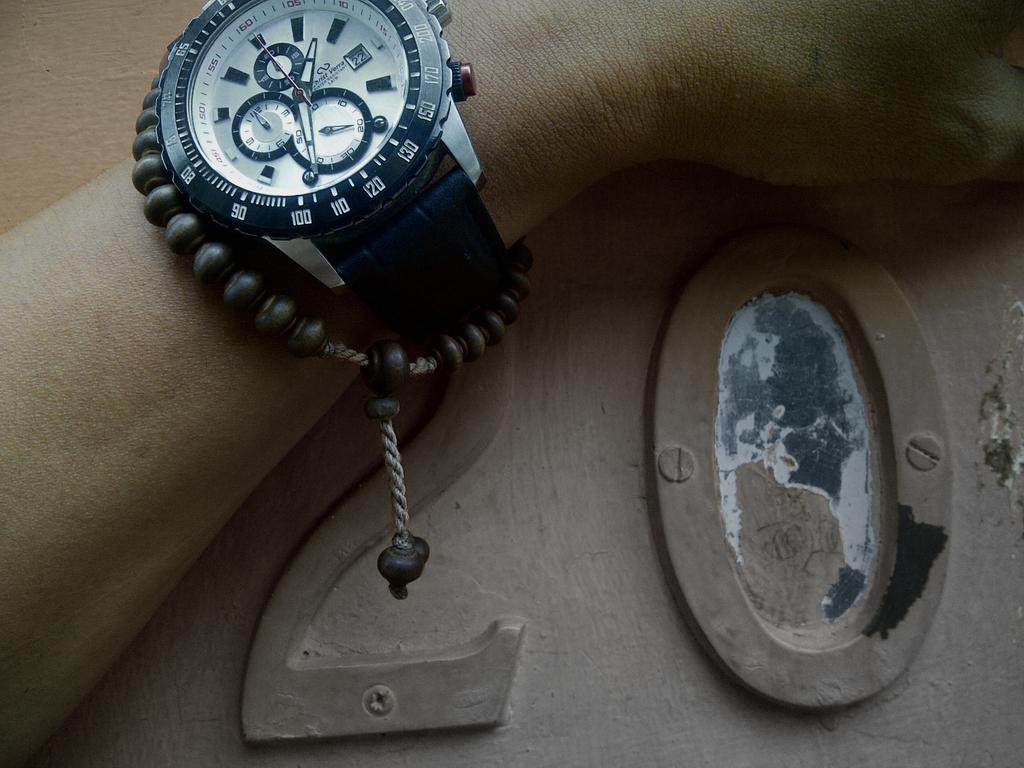Provide a one-sentence caption for the provided image. Man wearing a watch and resting his arm on a surface which has the number twenty written on it. 